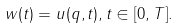Convert formula to latex. <formula><loc_0><loc_0><loc_500><loc_500>w ( t ) = u ( q , t ) , t \in [ 0 , T ] .</formula> 